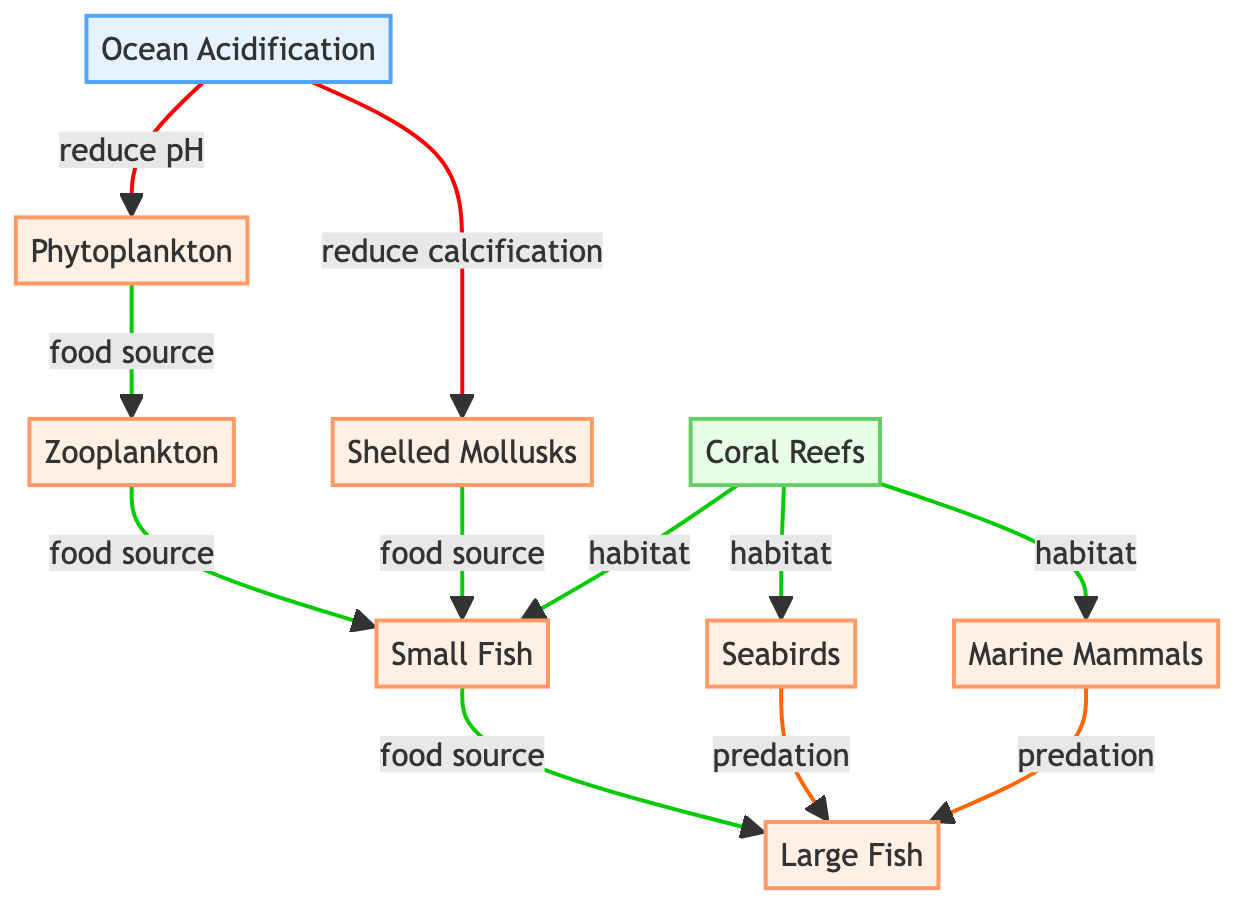What is the environmental factor represented in this diagram? The diagram clearly identifies "Ocean Acidification" as the only environmental factor. This is shown as the first node labeled "Ocean Acidification."
Answer: Ocean Acidification How many species are shown in the diagram? The diagram includes six nodes labeled as species: Phytoplankton, Zooplankton, Small Fish, Large Fish, Shelled Mollusks, Seabirds, and Marine Mammals. Counting these gives a total of six species.
Answer: Six How does ocean acidification affect phytoplankton? According to the diagram, ocean acidification reduces the pH, which leads to a negative effect on the growth or health of phytoplankton as indicated by the edge labeled "reduce pH."
Answer: Negative What type of relationship exists between zooplankton and small fish? The diagram indicates a positive relationship as zooplankton serve as a food source for small fish. This is represented by the edge labeled "food source."
Answer: Positive Which species is a food source for large fish? The diagram indicates that small fish are a food source for large fish as shown by the edge labeled "food source." This connection clearly points to small fish as a food source.
Answer: Small Fish How many habitats are associated with coral reefs in the diagram? Coral reefs are associated with three species in the diagram, namely small fish, seabirds, and marine mammals. Thus, there are three habitats connected to coral reefs.
Answer: Three Which species have a predation relationship on large fish? Both seabirds and marine mammals are shown to have a negative predation effect on large fish, as indicated by the edges labeled "predation." This means that they prey on large fish.
Answer: Seabirds and Marine Mammals What is the effect of ocean acidification on shelled mollusks? The diagram indicates that ocean acidification has a negative effect on shelled mollusks, specifically by reducing their calcification processes. This is captured by the edge labeled "reduce calcification."
Answer: Negative Are there any positive effects directly from ocean acidification on species interactions? The diagram shows that ocean acidification has only negative effects on the species directly, such as reducing pH and calcification. The positive relationships arise between species, not directly from ocean acidification.
Answer: No 